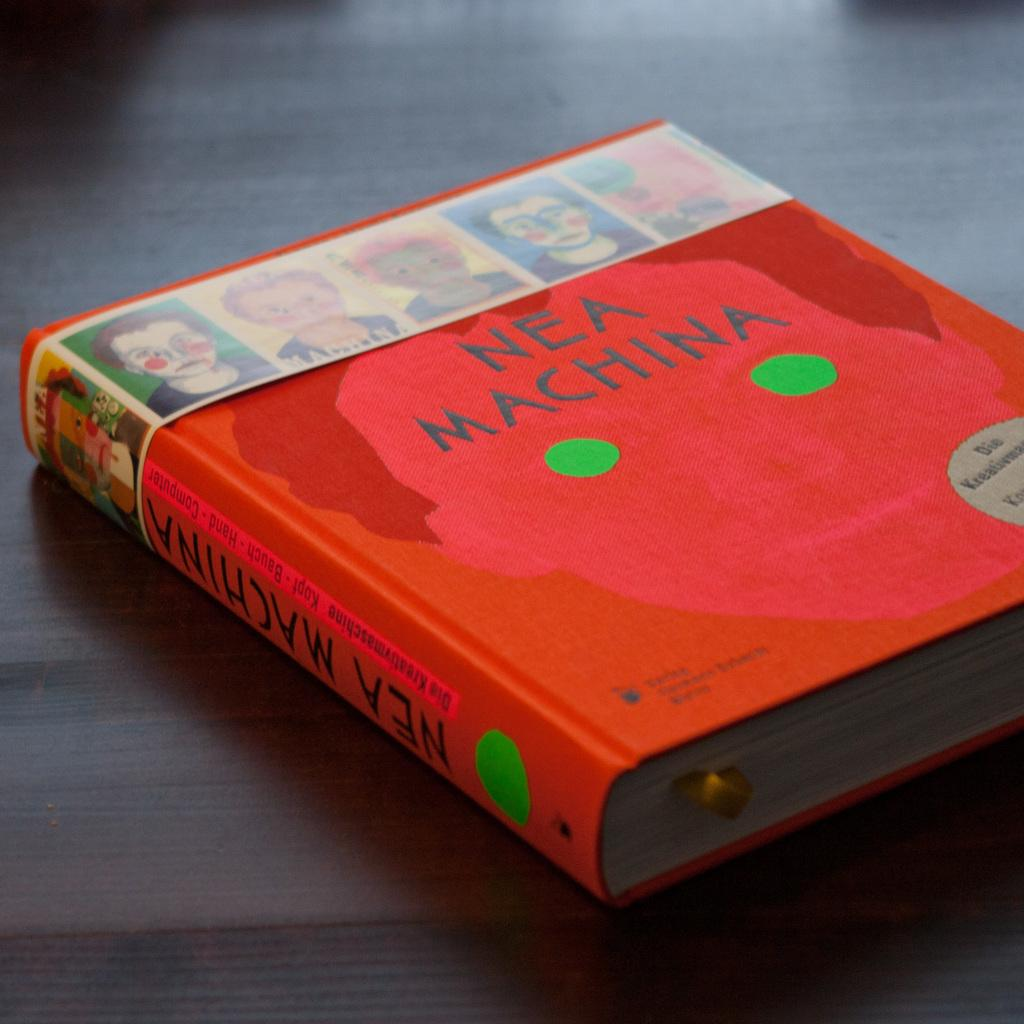Provide a one-sentence caption for the provided image. Nea Machina is an interesting read and a good book. 